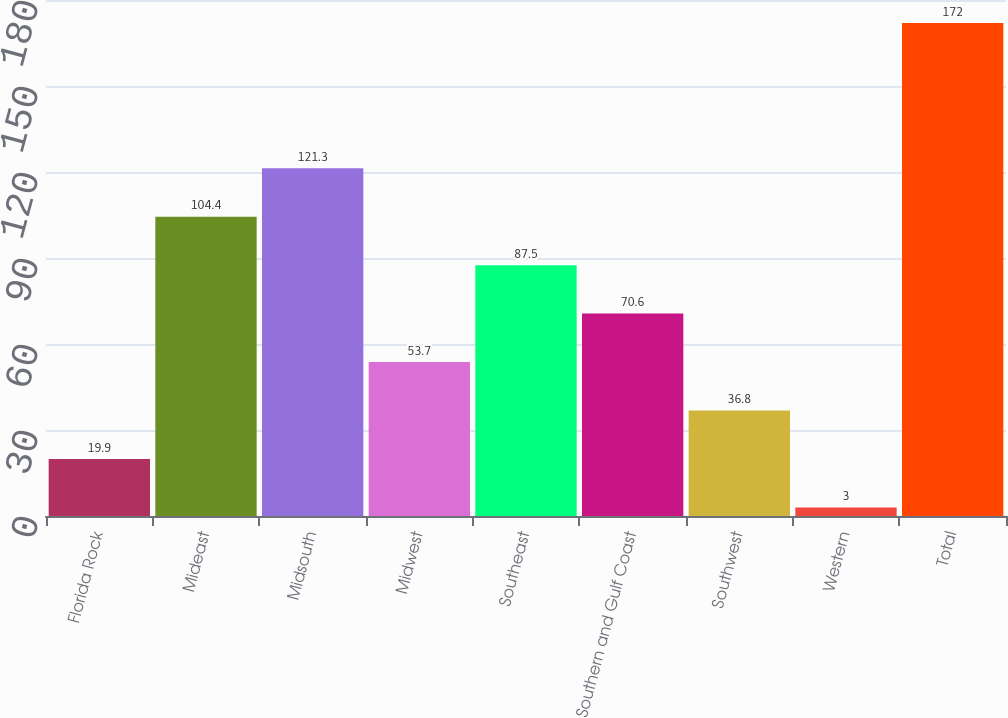Convert chart. <chart><loc_0><loc_0><loc_500><loc_500><bar_chart><fcel>Florida Rock<fcel>Mideast<fcel>Midsouth<fcel>Midwest<fcel>Southeast<fcel>Southern and Gulf Coast<fcel>Southwest<fcel>Western<fcel>Total<nl><fcel>19.9<fcel>104.4<fcel>121.3<fcel>53.7<fcel>87.5<fcel>70.6<fcel>36.8<fcel>3<fcel>172<nl></chart> 